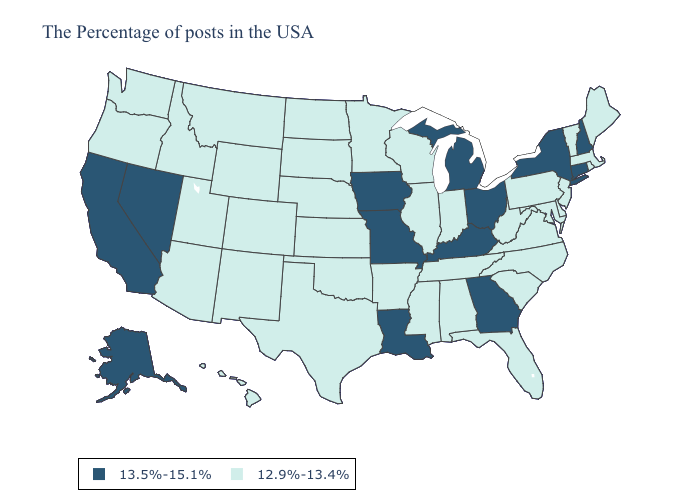Does Wisconsin have the highest value in the MidWest?
Concise answer only. No. What is the lowest value in the South?
Quick response, please. 12.9%-13.4%. Does California have the lowest value in the USA?
Be succinct. No. What is the value of West Virginia?
Keep it brief. 12.9%-13.4%. Name the states that have a value in the range 12.9%-13.4%?
Concise answer only. Maine, Massachusetts, Rhode Island, Vermont, New Jersey, Delaware, Maryland, Pennsylvania, Virginia, North Carolina, South Carolina, West Virginia, Florida, Indiana, Alabama, Tennessee, Wisconsin, Illinois, Mississippi, Arkansas, Minnesota, Kansas, Nebraska, Oklahoma, Texas, South Dakota, North Dakota, Wyoming, Colorado, New Mexico, Utah, Montana, Arizona, Idaho, Washington, Oregon, Hawaii. Does the map have missing data?
Concise answer only. No. What is the lowest value in states that border Arkansas?
Give a very brief answer. 12.9%-13.4%. What is the highest value in the South ?
Quick response, please. 13.5%-15.1%. Name the states that have a value in the range 13.5%-15.1%?
Give a very brief answer. New Hampshire, Connecticut, New York, Ohio, Georgia, Michigan, Kentucky, Louisiana, Missouri, Iowa, Nevada, California, Alaska. What is the highest value in the West ?
Write a very short answer. 13.5%-15.1%. What is the lowest value in states that border Alabama?
Concise answer only. 12.9%-13.4%. What is the value of South Dakota?
Keep it brief. 12.9%-13.4%. How many symbols are there in the legend?
Quick response, please. 2. Does Hawaii have the highest value in the West?
Concise answer only. No. 